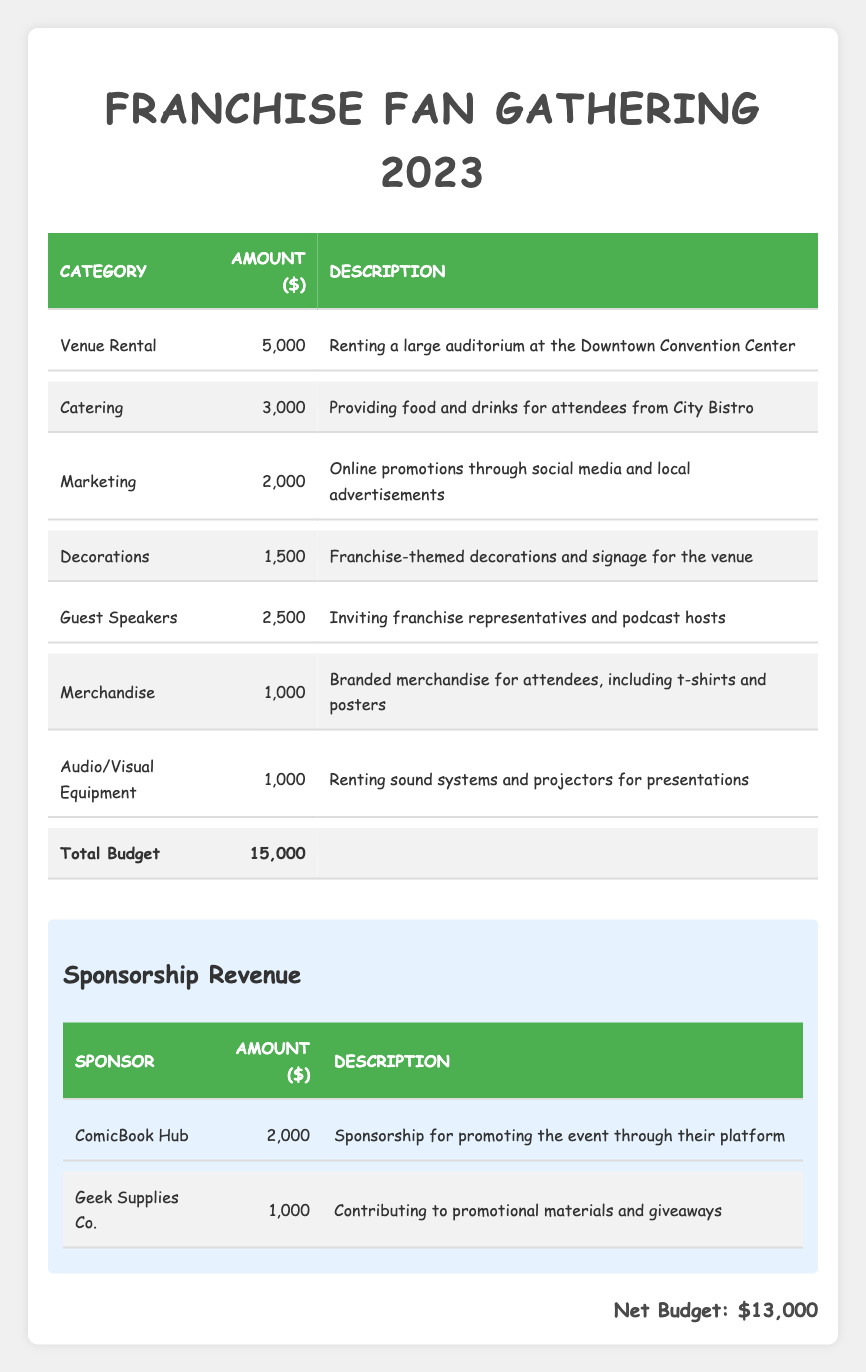What is the total budget allocated for the Franchise Fan Gathering 2023? The total budget is listed directly in the table under the "Total Budget" row, which shows the amount of $15,000.
Answer: 15000 How much was allocated for marketing expenses? In the expense allocation section, under the "Marketing" category, the amount allocated is $2,000.
Answer: 2000 Which expense category has the highest allocation and what is the amount? By examining the expense allocation rows, the "Venue Rental" category has the highest allocation, which is $5,000.
Answer: Venue Rental, 5000 What is the combined amount from sponsorship revenue? The sponsorship amounts from "ComicBook Hub" ($2,000) and "Geek Supplies Co." ($1,000) sum to $3,000. Calculation: 2000 + 1000 = 3000.
Answer: 3000 Is there an allocation for merchandise in the budget? The table lists an expense category for "Merchandise," indicating that there is indeed an allocation for it.
Answer: Yes What is the net budget after considering sponsorship revenue? To find the net budget, we subtract the total sponsorship revenue of $3,000 from the total budget of $15,000. Calculation: 15000 - 3000 = 12000. The net budget amount is reflected as $13,000, confirming the relationship.
Answer: 13000 How much more is allocated for catering compared to merchandise? The catering allocation is $3,000, and merchandise allocation is $1,000. The difference is calculated as follows: 3000 - 1000 = 2000.
Answer: 2000 Are the guest speakers' expenses higher than the combined merchandise and audio/visual equipment costs? The guest speakers' allocation is $2,500. The combined costs for merchandise ($1,000) and audio/visual equipment ($1,000) is $2,000. Since $2,500 > $2,000, this statement is true.
Answer: Yes How much percentage of the total budget is spent on decorations? The decoration expense is $1,500. To calculate the percentage: (1500 / 15000) * 100 = 10%. Thus, decorations constitute 10% of the total budget.
Answer: 10% 